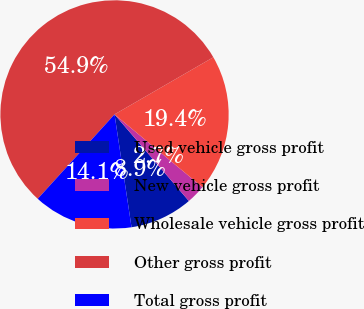Convert chart to OTSL. <chart><loc_0><loc_0><loc_500><loc_500><pie_chart><fcel>Used vehicle gross profit<fcel>New vehicle gross profit<fcel>Wholesale vehicle gross profit<fcel>Other gross profit<fcel>Total gross profit<nl><fcel>8.91%<fcel>2.7%<fcel>19.35%<fcel>54.9%<fcel>14.13%<nl></chart> 